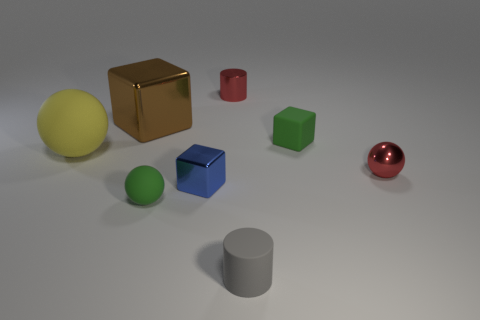Add 1 yellow matte balls. How many objects exist? 9 Subtract 1 green cubes. How many objects are left? 7 Subtract all cylinders. How many objects are left? 6 Subtract all big blue metallic things. Subtract all green balls. How many objects are left? 7 Add 6 gray objects. How many gray objects are left? 7 Add 8 tiny blue cubes. How many tiny blue cubes exist? 9 